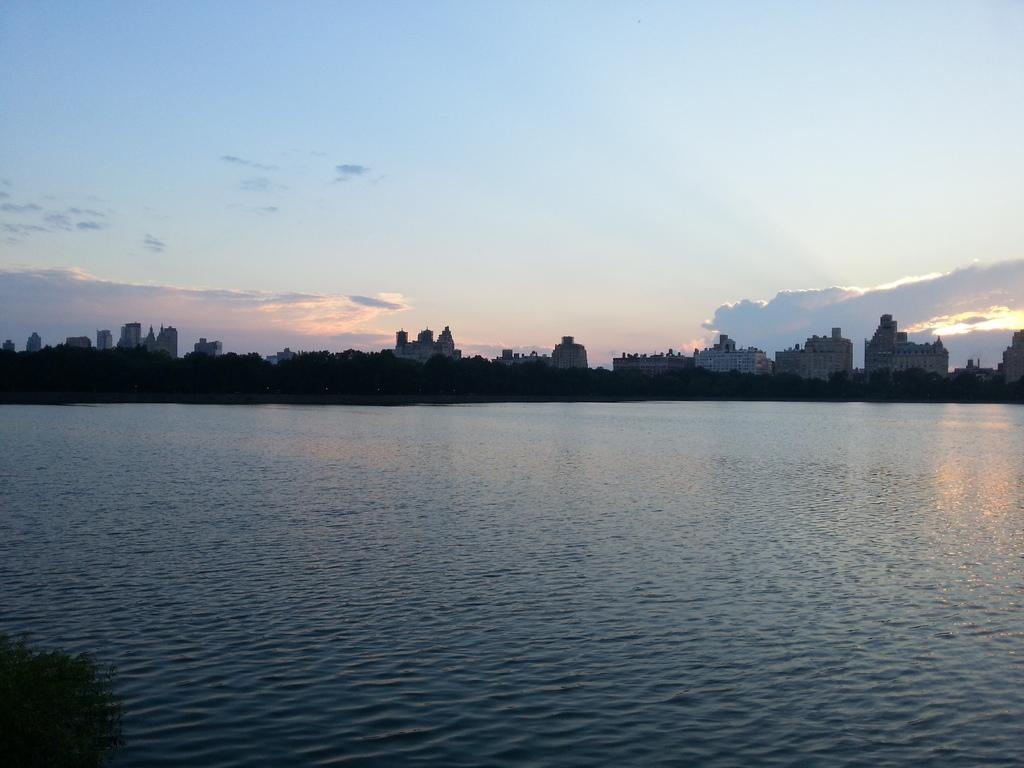What is the primary element visible in the image? There is water in the image. What type of natural vegetation can be seen in the image? There are trees in the image. What type of man-made structures are present in the image? There are buildings in the image. How would you describe the weather based on the image? The sky is cloudy in the image. How does the water express its feelings of hate in the image? The water does not express any feelings, as it is an inanimate object. 